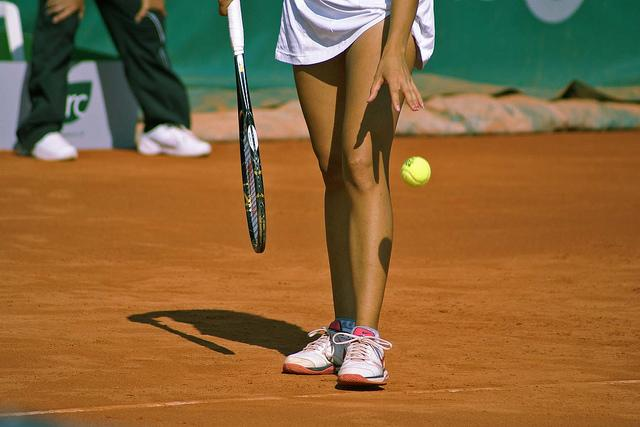What will the person here do next in the game?

Choices:
A) serve
B) rest
C) quit
D) return ball serve 